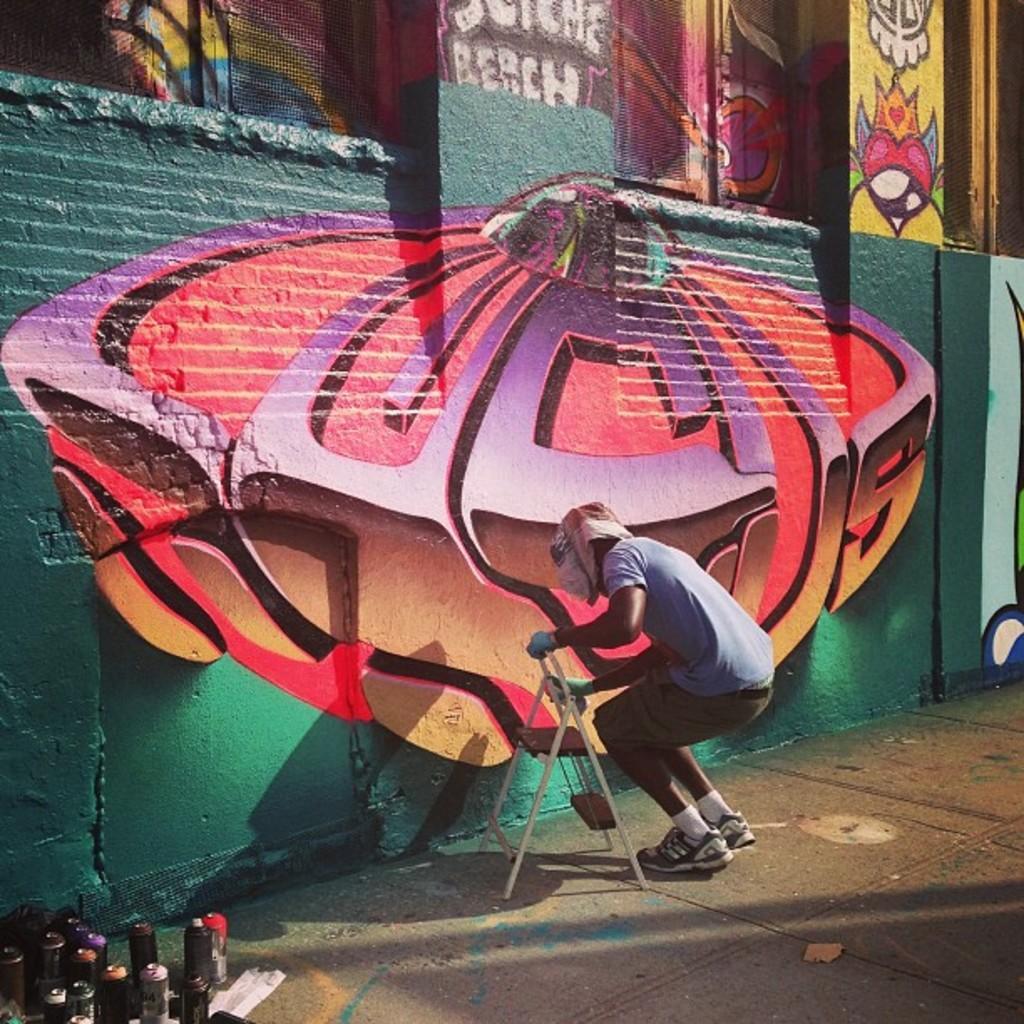Please provide a concise description of this image. In this image, I can see a person standing and holding an object. In the bottom left corner of the image, I can see the bottles. There is a graffiti painting on the wall. 